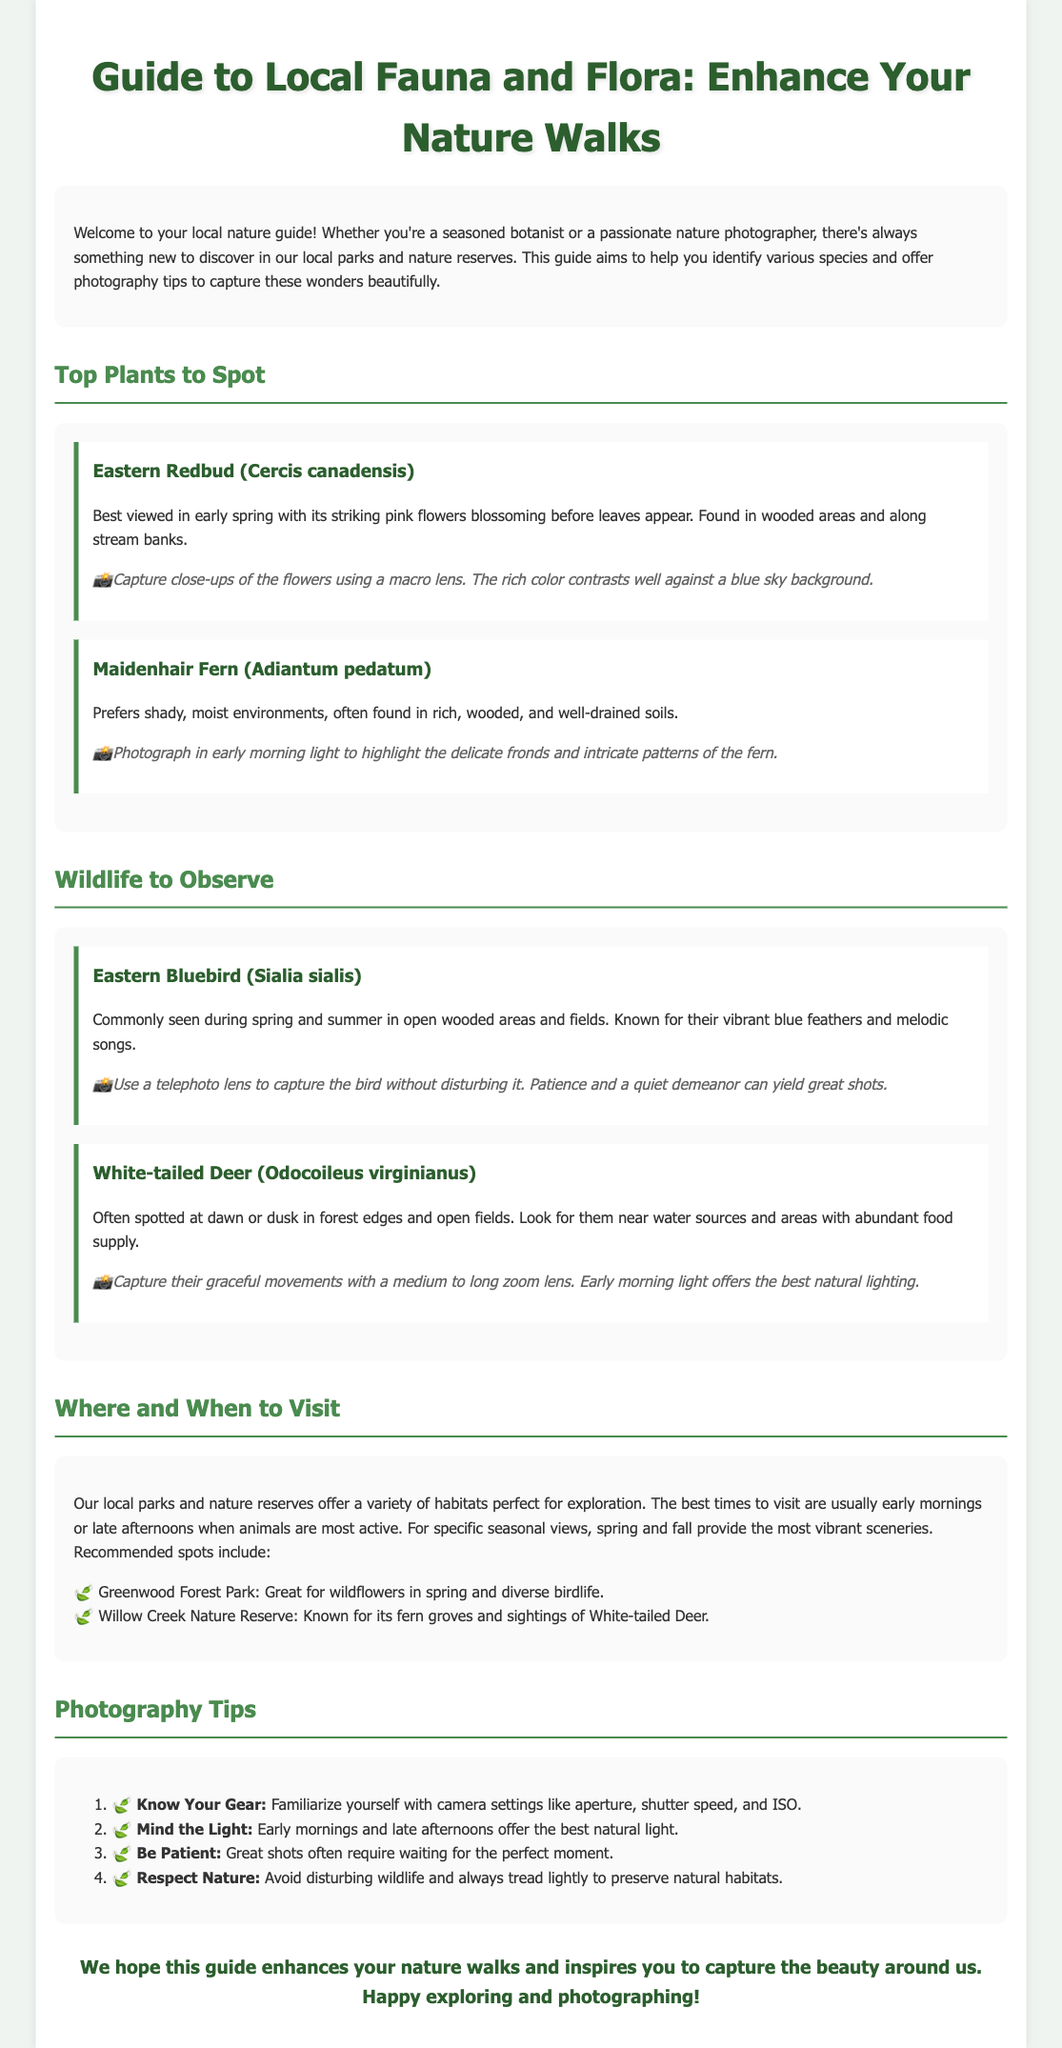What is the title of the guide? The title provides the main subject and focus of the document, which is "Guide to Local Fauna and Flora: Enhance Your Nature Walks."
Answer: Guide to Local Fauna and Flora: Enhance Your Nature Walks Which plant is best viewed in early spring? The document specifically mentions "Eastern Redbud" as the plant to be best viewed in early spring due to its flowers.
Answer: Eastern Redbud How many photography tips are provided in the document? The document lists a total of four photography tips under the photography tips section.
Answer: Four What is the habitat preference of Maidenhair Fern? The document states that Maidenhair Fern prefers shady, moist environments, which indicates its habitat.
Answer: Shady, moist environments Where can you find White-tailed Deer? The text indicates that White-tailed Deer can be spotted near water sources and areas with abundant food supply.
Answer: Near water sources and areas with abundant food supply What time of day is best for observing wildlife according to the document? The document suggests that early mornings and late afternoons are the best times for observing wildlife.
Answer: Early mornings and late afternoons Which lens should be used to capture the Eastern Bluebird? The document advises using a telephoto lens to capture the Eastern Bluebird effectively.
Answer: Telephoto lens What are two recommended spots for nature walks mentioned in the document? The document specifically mentions "Greenwood Forest Park" and "Willow Creek Nature Reserve" as recommended spots.
Answer: Greenwood Forest Park and Willow Creek Nature Reserve 